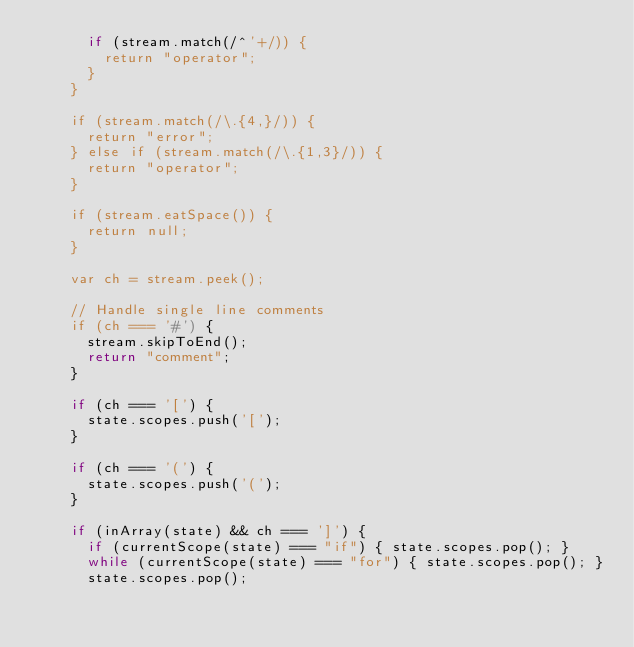<code> <loc_0><loc_0><loc_500><loc_500><_JavaScript_>      if (stream.match(/^'+/)) {
        return "operator";
      }
    }

    if (stream.match(/\.{4,}/)) {
      return "error";
    } else if (stream.match(/\.{1,3}/)) {
      return "operator";
    }

    if (stream.eatSpace()) {
      return null;
    }

    var ch = stream.peek();

    // Handle single line comments
    if (ch === '#') {
      stream.skipToEnd();
      return "comment";
    }

    if (ch === '[') {
      state.scopes.push('[');
    }

    if (ch === '(') {
      state.scopes.push('(');
    }

    if (inArray(state) && ch === ']') {
      if (currentScope(state) === "if") { state.scopes.pop(); }
      while (currentScope(state) === "for") { state.scopes.pop(); }
      state.scopes.pop();</code> 